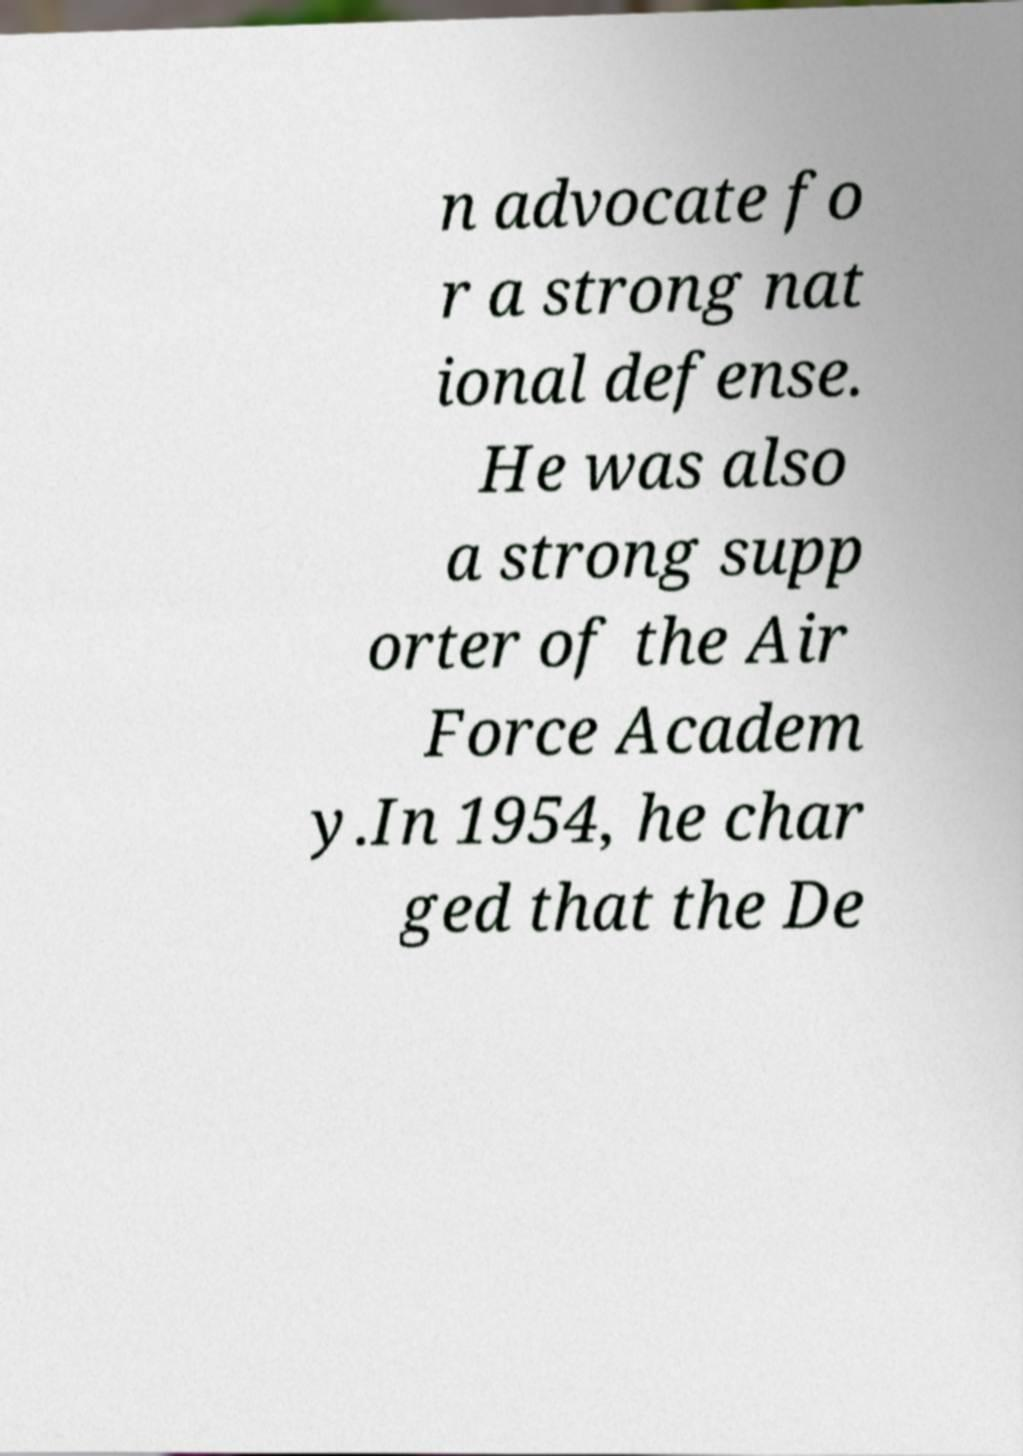Can you accurately transcribe the text from the provided image for me? n advocate fo r a strong nat ional defense. He was also a strong supp orter of the Air Force Academ y.In 1954, he char ged that the De 